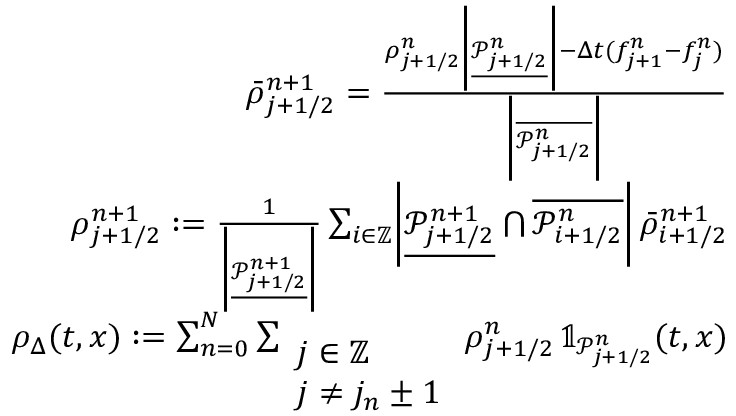<formula> <loc_0><loc_0><loc_500><loc_500>\begin{array} { r } { \bar { \rho } _ { j + 1 / 2 } ^ { n + 1 } = \frac { \rho _ { j + 1 / 2 } ^ { n } \left | \underline { { \mathcal { P } _ { j + 1 / 2 } ^ { n } } } \right | - \Delta t ( f _ { j + 1 } ^ { n } - f _ { j } ^ { n } ) } { \left | \overline { { \mathcal { P } _ { j + 1 / 2 } ^ { n } } } \right | } } \\ { \rho _ { j + 1 / 2 } ^ { n + 1 } \colon = \frac { 1 } { \left | \underline { { \mathcal { P } _ { j + 1 / 2 } ^ { n + 1 } } } \right | } \sum _ { i \in \mathbb { Z } } \left | \underline { { \mathcal { P } _ { j + 1 / 2 } ^ { n + 1 } } } \bigcap \overline { { \mathcal { P } _ { i + 1 / 2 } ^ { n } } } \right | \, \bar { \rho } _ { i + 1 / 2 } ^ { n + 1 } } \\ { \rho _ { \Delta } ( t , x ) \colon = \sum _ { n = 0 } ^ { N } \sum _ { \begin{array} { l } { j \in \mathbb { Z } } \\ { j \neq j _ { n } \pm 1 } \end{array} } \rho _ { j + 1 / 2 } ^ { n } \, \mathbb { 1 } _ { \mathcal { P } _ { j + 1 / 2 } ^ { n } } ( t , x ) } \end{array}</formula> 